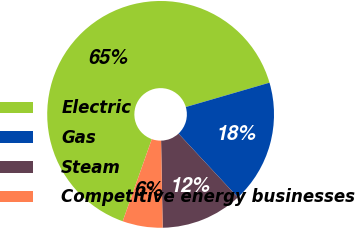Convert chart. <chart><loc_0><loc_0><loc_500><loc_500><pie_chart><fcel>Electric<fcel>Gas<fcel>Steam<fcel>Competitive energy businesses<nl><fcel>65.07%<fcel>17.58%<fcel>11.64%<fcel>5.71%<nl></chart> 